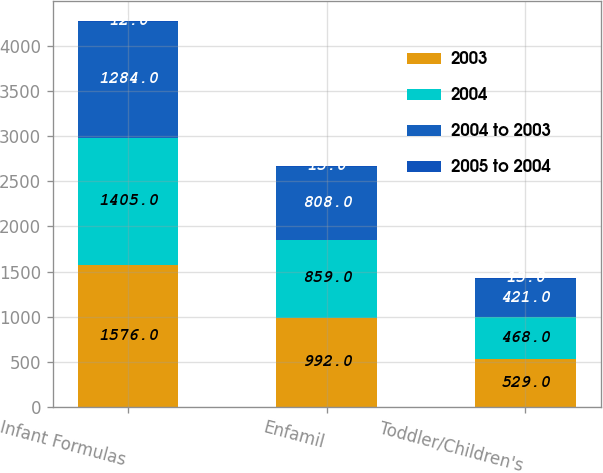<chart> <loc_0><loc_0><loc_500><loc_500><stacked_bar_chart><ecel><fcel>Infant Formulas<fcel>Enfamil<fcel>Toddler/Children's<nl><fcel>2003<fcel>1576<fcel>992<fcel>529<nl><fcel>2004<fcel>1405<fcel>859<fcel>468<nl><fcel>2004 to 2003<fcel>1284<fcel>808<fcel>421<nl><fcel>2005 to 2004<fcel>12<fcel>15<fcel>13<nl></chart> 